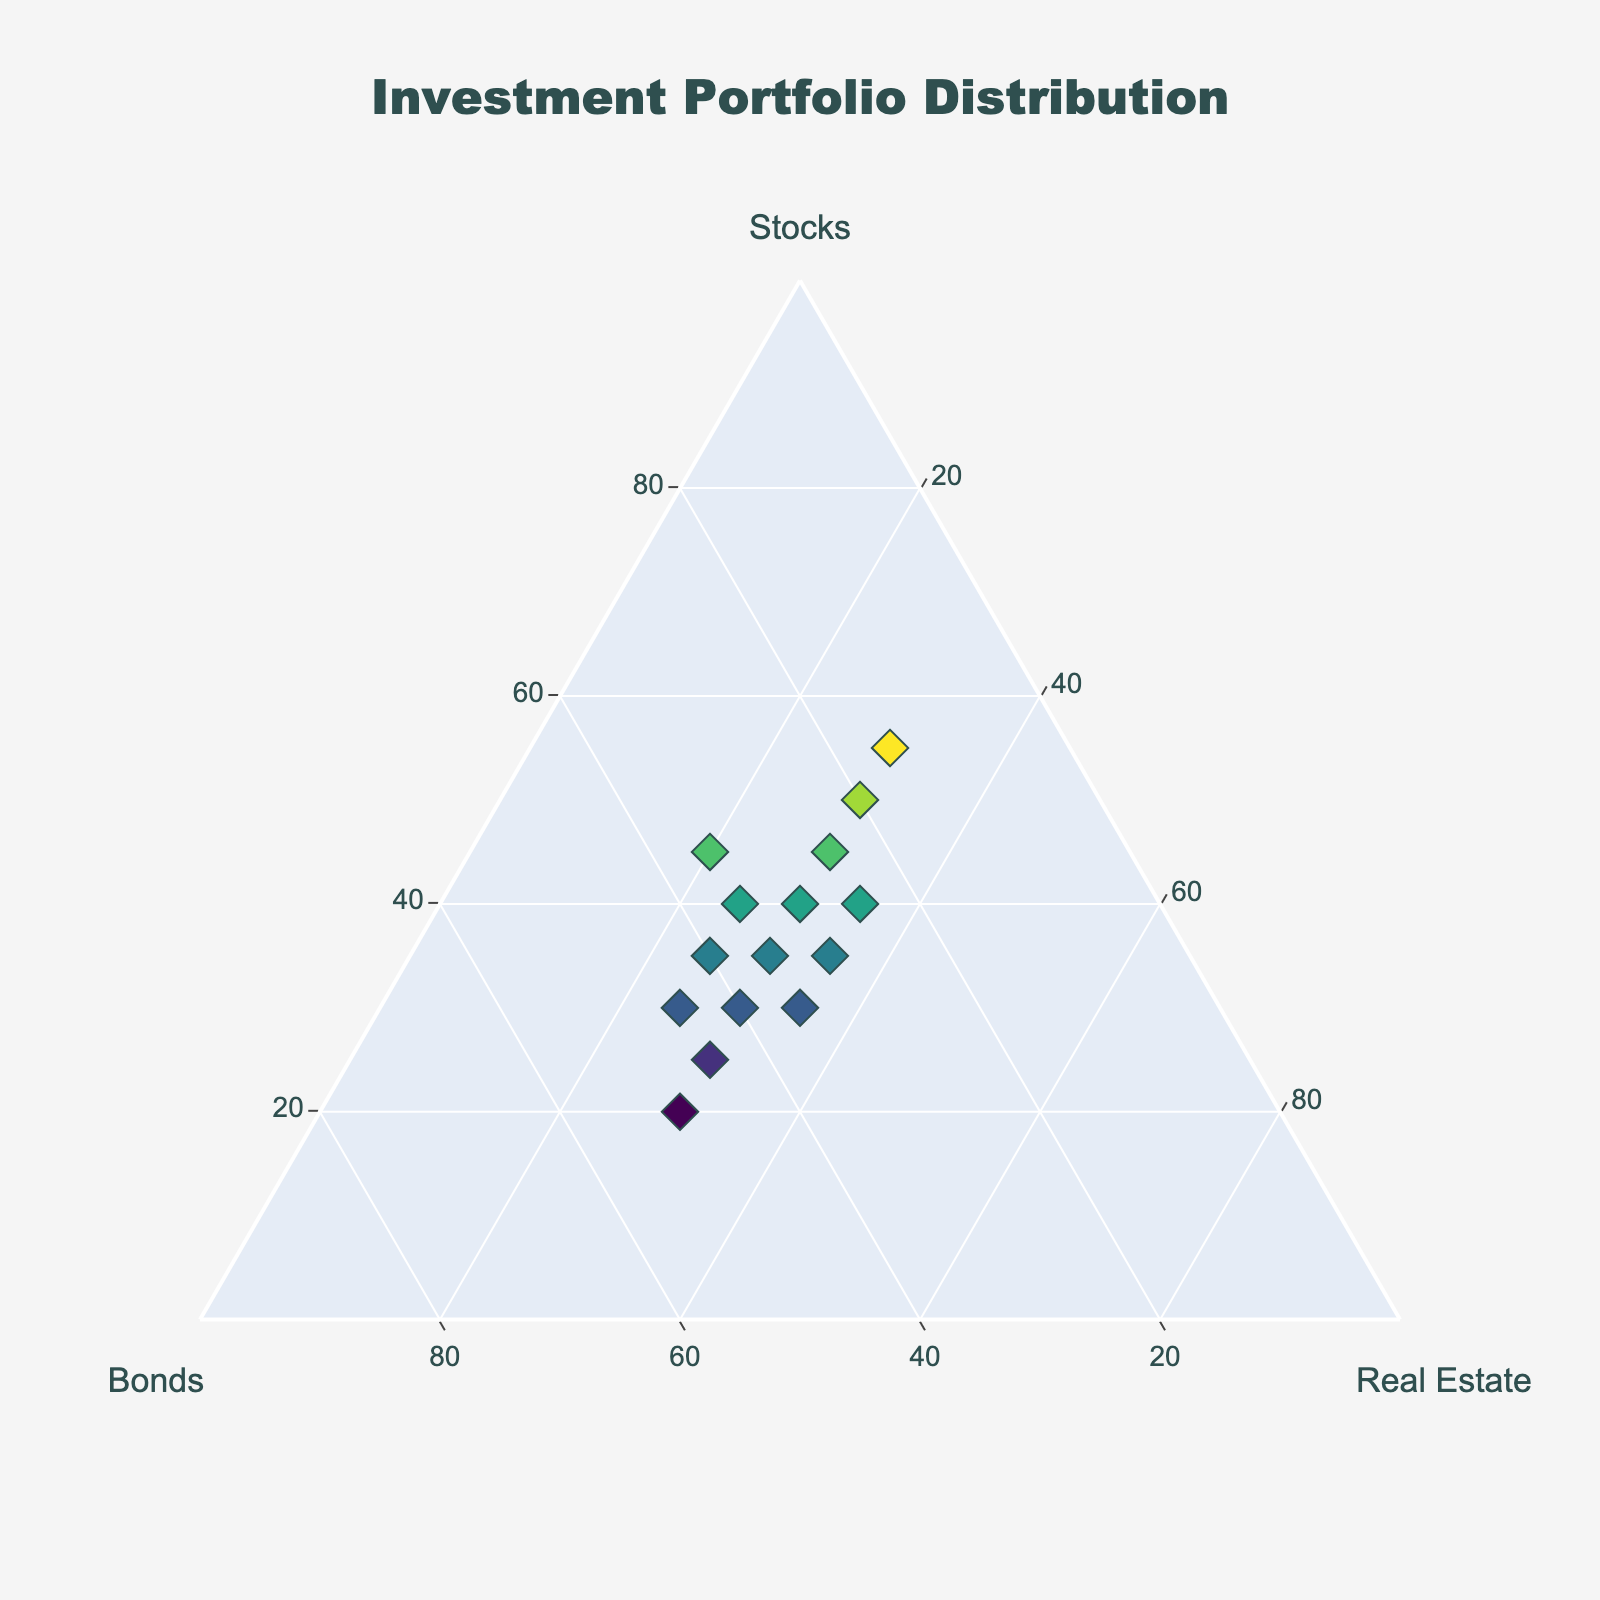What's the title of the figure? The title of the figure is prominently displayed at the top of the plot. By visually inspecting the figure, the title reads "Investment Portfolio Distribution".
Answer: Investment Portfolio Distribution How many data points are there in the plot? Each data point is represented by a marker on the ternary plot. By counting the markers, there are 15 data points in total.
Answer: 15 Which investment type is represented by the 'a' axis? The axes of the ternary plot are labeled with titles indicating which investment type each represents. The 'a' axis is labeled as 'Stocks'.
Answer: Stocks What are the proportions of the point with the highest stock percentage? The data points include text information when hovered over, showing the proportions of stocks, bonds, and real estate. The highest stock percentage is 55%, with the corresponding proportions being 55% stocks, 15% bonds, 30% real estate.
Answer: 55% stocks, 15% bonds, 30% real estate Which data points have equal proportions of bonds and real estate? By inspecting the data and the plot, we can observe the text associated with each marker. The points where the bond and real estate percentages are equal are found to be 35% bonds and 35% real estate. These are two points with the following proportions: 30% stocks, 35% bonds, 35% real estate and 35% stocks, 35% bonds, 30% real estate.
Answer: 30% stocks, 35% bonds, 35% real estate and 35% stocks, 35% bonds, 30% real estate Are there any data points where bonds have the highest proportion? Inspecting each of the data points' proportions from the plot, we can determine if any point has bonds as the highest proportion. The highest bond proportion in the points is 50%, and the corresponding data point is 20% stocks, 50% bonds, 30% real estate.
Answer: Yes, 20% stocks, 50% bonds, 30% real estate Which investment type is more frequently the largest proportion? By analyzing the data, we can count which investment type has the highest proportion in each data point. Stocks appear to be the highest proportion more frequently than bonds and real estate.
Answer: Stocks What is the average stock percentage across all data points? Sum all stock percentages and divide by the number of data points. The sum of stocks is 525 (45+30+25+20+35+40+50+30+40+35+45+30+35+40+55)%, dividing by 15 data points gives an average of 35%.
Answer: 35% Which data point has the closest proportions of all three investments? The point with the most balanced proportions of stocks, bonds, and real estate would be the closest to the center of the ternary plot. The point with proportions 35% stocks, 30% bonds, 35% real estate and 30% stocks, 35% bonds, 35% real estate are the most balanced.
Answer: 35% stocks, 30% bonds, 35% real estate and 30% stocks, 35% bonds, 35% real estate 